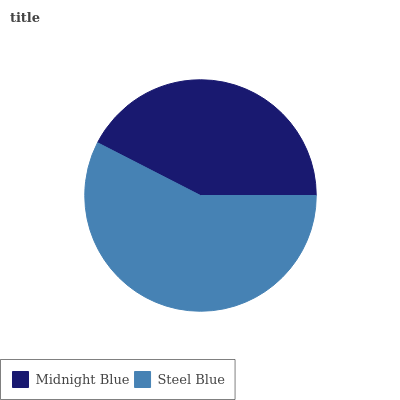Is Midnight Blue the minimum?
Answer yes or no. Yes. Is Steel Blue the maximum?
Answer yes or no. Yes. Is Steel Blue the minimum?
Answer yes or no. No. Is Steel Blue greater than Midnight Blue?
Answer yes or no. Yes. Is Midnight Blue less than Steel Blue?
Answer yes or no. Yes. Is Midnight Blue greater than Steel Blue?
Answer yes or no. No. Is Steel Blue less than Midnight Blue?
Answer yes or no. No. Is Steel Blue the high median?
Answer yes or no. Yes. Is Midnight Blue the low median?
Answer yes or no. Yes. Is Midnight Blue the high median?
Answer yes or no. No. Is Steel Blue the low median?
Answer yes or no. No. 